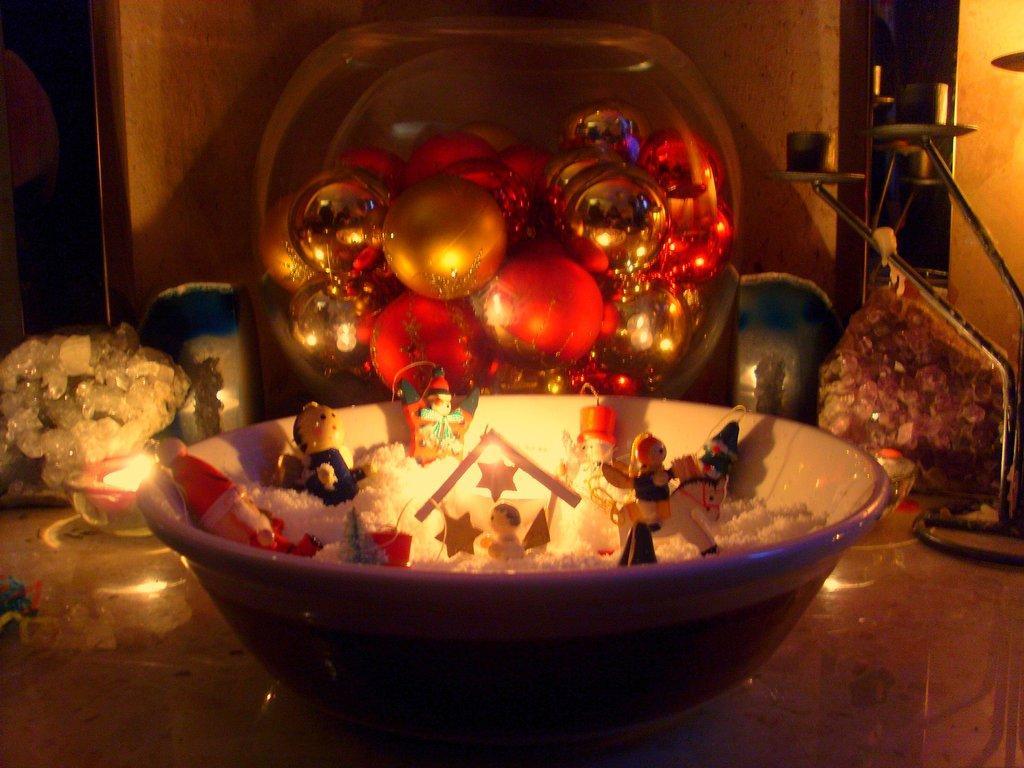In one or two sentences, can you explain what this image depicts? In this picture I can see a bowl in which there are few toys and in the background I see few decoration things. 